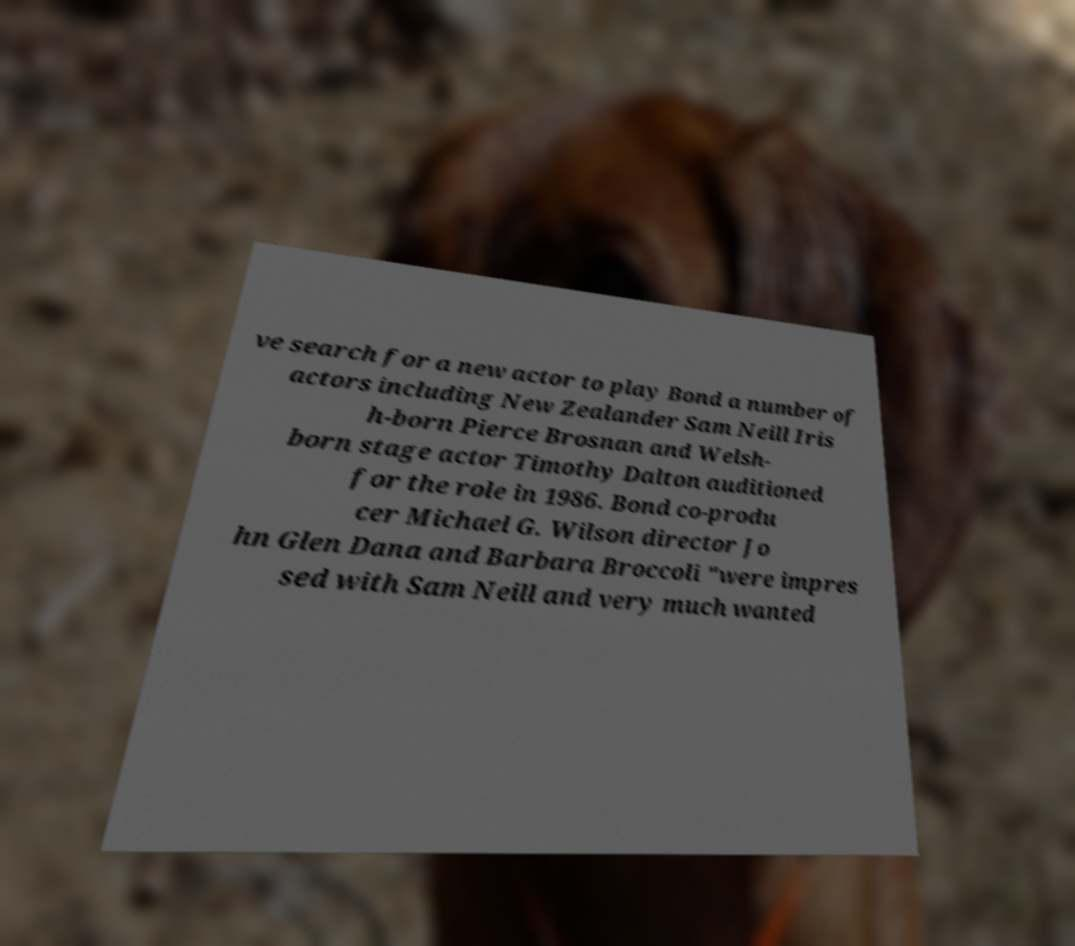Can you read and provide the text displayed in the image?This photo seems to have some interesting text. Can you extract and type it out for me? ve search for a new actor to play Bond a number of actors including New Zealander Sam Neill Iris h-born Pierce Brosnan and Welsh- born stage actor Timothy Dalton auditioned for the role in 1986. Bond co-produ cer Michael G. Wilson director Jo hn Glen Dana and Barbara Broccoli "were impres sed with Sam Neill and very much wanted 